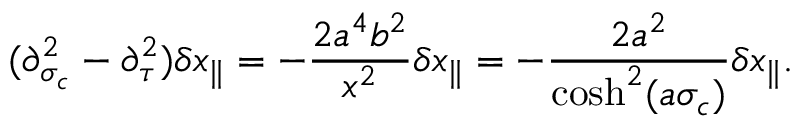<formula> <loc_0><loc_0><loc_500><loc_500>( \partial _ { \sigma _ { c } } ^ { 2 } - \partial _ { \tau } ^ { 2 } ) \delta x _ { \| } = - \frac { 2 a ^ { 4 } b ^ { 2 } } { x ^ { 2 } } \delta x _ { \| } = - \frac { 2 a ^ { 2 } } { \cosh ^ { 2 } ( a \sigma _ { c } ) } \delta x _ { \| } .</formula> 